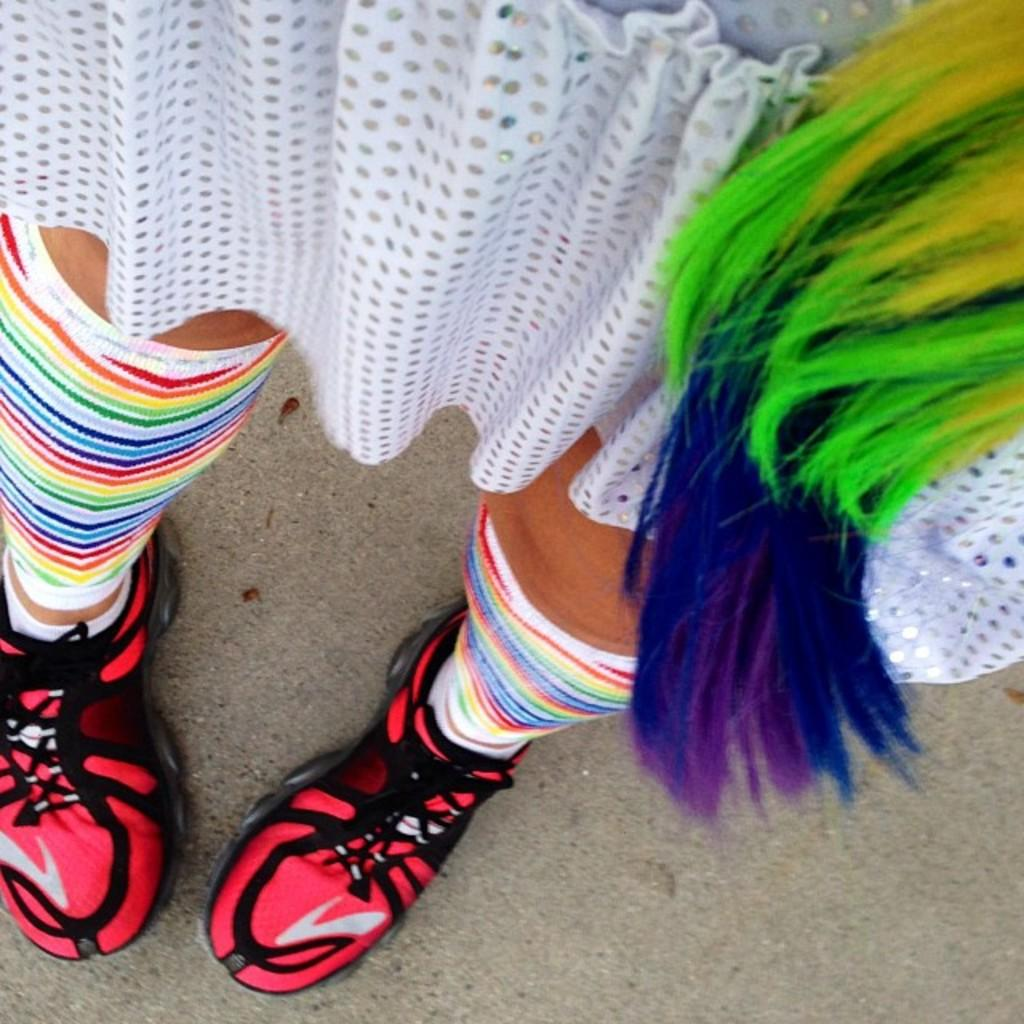Who or what is present in the image? There is a person in the image. What part of the person's body can be seen? The person's legs are visible. What type of clothing is the person wearing? The person is wearing a dress. What type of footwear is the person wearing? The person is wearing shoes. What is visible at the bottom of the image? The floor is visible at the bottom of the image. What type of learning material is being advertised in the image? There is no learning material or advertisement present in the image; it features a person with visible legs, wearing a dress, socks, and shoes. 